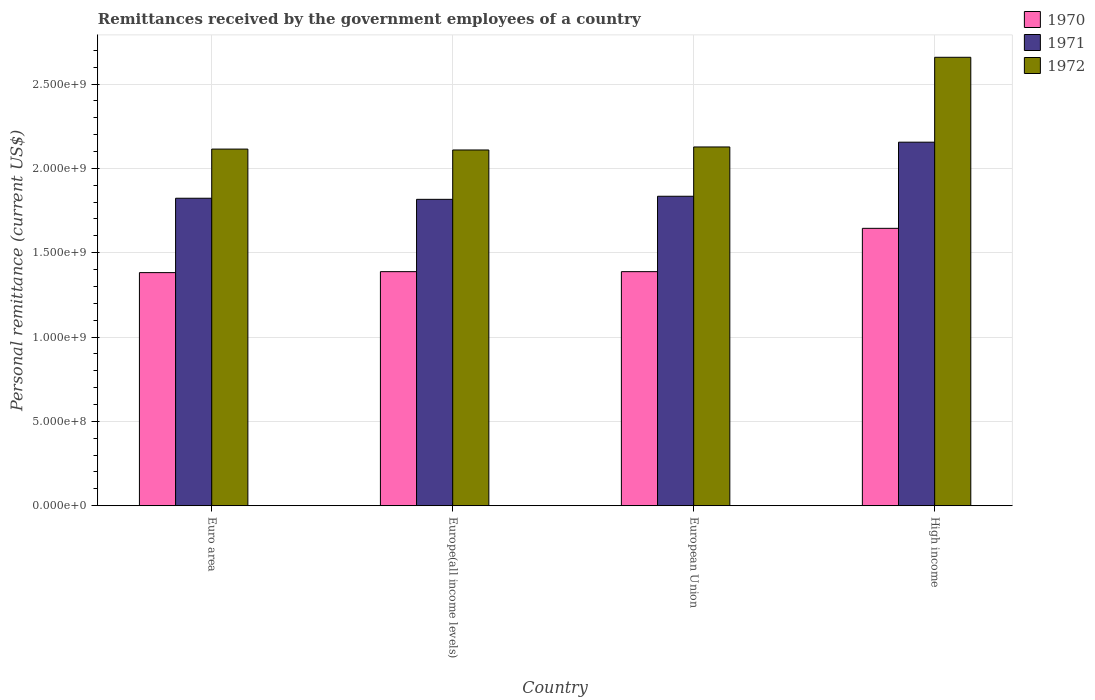How many groups of bars are there?
Make the answer very short. 4. Are the number of bars per tick equal to the number of legend labels?
Provide a short and direct response. Yes. Are the number of bars on each tick of the X-axis equal?
Give a very brief answer. Yes. How many bars are there on the 3rd tick from the right?
Your answer should be compact. 3. What is the label of the 4th group of bars from the left?
Your response must be concise. High income. What is the remittances received by the government employees in 1971 in European Union?
Offer a terse response. 1.83e+09. Across all countries, what is the maximum remittances received by the government employees in 1970?
Keep it short and to the point. 1.64e+09. Across all countries, what is the minimum remittances received by the government employees in 1972?
Your answer should be compact. 2.11e+09. In which country was the remittances received by the government employees in 1972 maximum?
Provide a short and direct response. High income. In which country was the remittances received by the government employees in 1972 minimum?
Provide a succinct answer. Europe(all income levels). What is the total remittances received by the government employees in 1971 in the graph?
Make the answer very short. 7.63e+09. What is the difference between the remittances received by the government employees in 1970 in Europe(all income levels) and that in High income?
Your response must be concise. -2.57e+08. What is the difference between the remittances received by the government employees in 1970 in High income and the remittances received by the government employees in 1971 in Euro area?
Provide a short and direct response. -1.78e+08. What is the average remittances received by the government employees in 1970 per country?
Your answer should be very brief. 1.45e+09. What is the difference between the remittances received by the government employees of/in 1972 and remittances received by the government employees of/in 1971 in European Union?
Make the answer very short. 2.92e+08. In how many countries, is the remittances received by the government employees in 1970 greater than 2400000000 US$?
Offer a terse response. 0. Is the remittances received by the government employees in 1972 in Euro area less than that in European Union?
Ensure brevity in your answer.  Yes. What is the difference between the highest and the second highest remittances received by the government employees in 1971?
Your response must be concise. -1.17e+07. What is the difference between the highest and the lowest remittances received by the government employees in 1970?
Provide a short and direct response. 2.63e+08. In how many countries, is the remittances received by the government employees in 1970 greater than the average remittances received by the government employees in 1970 taken over all countries?
Keep it short and to the point. 1. Is the sum of the remittances received by the government employees in 1971 in Euro area and European Union greater than the maximum remittances received by the government employees in 1972 across all countries?
Your answer should be very brief. Yes. Is it the case that in every country, the sum of the remittances received by the government employees in 1970 and remittances received by the government employees in 1972 is greater than the remittances received by the government employees in 1971?
Ensure brevity in your answer.  Yes. How many bars are there?
Offer a very short reply. 12. Are all the bars in the graph horizontal?
Provide a short and direct response. No. How many countries are there in the graph?
Offer a terse response. 4. Does the graph contain grids?
Make the answer very short. Yes. How are the legend labels stacked?
Ensure brevity in your answer.  Vertical. What is the title of the graph?
Offer a very short reply. Remittances received by the government employees of a country. Does "1987" appear as one of the legend labels in the graph?
Make the answer very short. No. What is the label or title of the Y-axis?
Your answer should be very brief. Personal remittance (current US$). What is the Personal remittance (current US$) of 1970 in Euro area?
Your response must be concise. 1.38e+09. What is the Personal remittance (current US$) in 1971 in Euro area?
Offer a terse response. 1.82e+09. What is the Personal remittance (current US$) of 1972 in Euro area?
Provide a succinct answer. 2.11e+09. What is the Personal remittance (current US$) of 1970 in Europe(all income levels)?
Offer a terse response. 1.39e+09. What is the Personal remittance (current US$) of 1971 in Europe(all income levels)?
Make the answer very short. 1.82e+09. What is the Personal remittance (current US$) in 1972 in Europe(all income levels)?
Provide a succinct answer. 2.11e+09. What is the Personal remittance (current US$) in 1970 in European Union?
Provide a succinct answer. 1.39e+09. What is the Personal remittance (current US$) of 1971 in European Union?
Provide a succinct answer. 1.83e+09. What is the Personal remittance (current US$) in 1972 in European Union?
Make the answer very short. 2.13e+09. What is the Personal remittance (current US$) of 1970 in High income?
Ensure brevity in your answer.  1.64e+09. What is the Personal remittance (current US$) in 1971 in High income?
Keep it short and to the point. 2.16e+09. What is the Personal remittance (current US$) of 1972 in High income?
Give a very brief answer. 2.66e+09. Across all countries, what is the maximum Personal remittance (current US$) in 1970?
Give a very brief answer. 1.64e+09. Across all countries, what is the maximum Personal remittance (current US$) in 1971?
Provide a succinct answer. 2.16e+09. Across all countries, what is the maximum Personal remittance (current US$) of 1972?
Give a very brief answer. 2.66e+09. Across all countries, what is the minimum Personal remittance (current US$) of 1970?
Ensure brevity in your answer.  1.38e+09. Across all countries, what is the minimum Personal remittance (current US$) of 1971?
Keep it short and to the point. 1.82e+09. Across all countries, what is the minimum Personal remittance (current US$) in 1972?
Make the answer very short. 2.11e+09. What is the total Personal remittance (current US$) in 1970 in the graph?
Offer a very short reply. 5.80e+09. What is the total Personal remittance (current US$) of 1971 in the graph?
Ensure brevity in your answer.  7.63e+09. What is the total Personal remittance (current US$) of 1972 in the graph?
Your answer should be compact. 9.01e+09. What is the difference between the Personal remittance (current US$) of 1970 in Euro area and that in Europe(all income levels)?
Provide a succinct answer. -5.80e+06. What is the difference between the Personal remittance (current US$) of 1971 in Euro area and that in Europe(all income levels)?
Give a very brief answer. 6.47e+06. What is the difference between the Personal remittance (current US$) of 1972 in Euro area and that in Europe(all income levels)?
Make the answer very short. 5.22e+06. What is the difference between the Personal remittance (current US$) of 1970 in Euro area and that in European Union?
Make the answer very short. -5.80e+06. What is the difference between the Personal remittance (current US$) in 1971 in Euro area and that in European Union?
Your answer should be very brief. -1.17e+07. What is the difference between the Personal remittance (current US$) in 1972 in Euro area and that in European Union?
Your response must be concise. -1.26e+07. What is the difference between the Personal remittance (current US$) in 1970 in Euro area and that in High income?
Offer a very short reply. -2.63e+08. What is the difference between the Personal remittance (current US$) of 1971 in Euro area and that in High income?
Your answer should be compact. -3.32e+08. What is the difference between the Personal remittance (current US$) in 1972 in Euro area and that in High income?
Your response must be concise. -5.44e+08. What is the difference between the Personal remittance (current US$) in 1971 in Europe(all income levels) and that in European Union?
Provide a succinct answer. -1.82e+07. What is the difference between the Personal remittance (current US$) in 1972 in Europe(all income levels) and that in European Union?
Provide a short and direct response. -1.78e+07. What is the difference between the Personal remittance (current US$) of 1970 in Europe(all income levels) and that in High income?
Offer a terse response. -2.57e+08. What is the difference between the Personal remittance (current US$) of 1971 in Europe(all income levels) and that in High income?
Offer a terse response. -3.39e+08. What is the difference between the Personal remittance (current US$) of 1972 in Europe(all income levels) and that in High income?
Your answer should be very brief. -5.49e+08. What is the difference between the Personal remittance (current US$) of 1970 in European Union and that in High income?
Provide a short and direct response. -2.57e+08. What is the difference between the Personal remittance (current US$) of 1971 in European Union and that in High income?
Provide a succinct answer. -3.21e+08. What is the difference between the Personal remittance (current US$) in 1972 in European Union and that in High income?
Your answer should be compact. -5.32e+08. What is the difference between the Personal remittance (current US$) of 1970 in Euro area and the Personal remittance (current US$) of 1971 in Europe(all income levels)?
Your answer should be compact. -4.35e+08. What is the difference between the Personal remittance (current US$) of 1970 in Euro area and the Personal remittance (current US$) of 1972 in Europe(all income levels)?
Your response must be concise. -7.27e+08. What is the difference between the Personal remittance (current US$) of 1971 in Euro area and the Personal remittance (current US$) of 1972 in Europe(all income levels)?
Your answer should be very brief. -2.86e+08. What is the difference between the Personal remittance (current US$) in 1970 in Euro area and the Personal remittance (current US$) in 1971 in European Union?
Give a very brief answer. -4.53e+08. What is the difference between the Personal remittance (current US$) of 1970 in Euro area and the Personal remittance (current US$) of 1972 in European Union?
Ensure brevity in your answer.  -7.45e+08. What is the difference between the Personal remittance (current US$) of 1971 in Euro area and the Personal remittance (current US$) of 1972 in European Union?
Keep it short and to the point. -3.04e+08. What is the difference between the Personal remittance (current US$) of 1970 in Euro area and the Personal remittance (current US$) of 1971 in High income?
Give a very brief answer. -7.73e+08. What is the difference between the Personal remittance (current US$) of 1970 in Euro area and the Personal remittance (current US$) of 1972 in High income?
Your response must be concise. -1.28e+09. What is the difference between the Personal remittance (current US$) of 1971 in Euro area and the Personal remittance (current US$) of 1972 in High income?
Keep it short and to the point. -8.36e+08. What is the difference between the Personal remittance (current US$) in 1970 in Europe(all income levels) and the Personal remittance (current US$) in 1971 in European Union?
Your response must be concise. -4.47e+08. What is the difference between the Personal remittance (current US$) in 1970 in Europe(all income levels) and the Personal remittance (current US$) in 1972 in European Union?
Offer a very short reply. -7.39e+08. What is the difference between the Personal remittance (current US$) in 1971 in Europe(all income levels) and the Personal remittance (current US$) in 1972 in European Union?
Your answer should be compact. -3.10e+08. What is the difference between the Personal remittance (current US$) of 1970 in Europe(all income levels) and the Personal remittance (current US$) of 1971 in High income?
Provide a succinct answer. -7.68e+08. What is the difference between the Personal remittance (current US$) of 1970 in Europe(all income levels) and the Personal remittance (current US$) of 1972 in High income?
Make the answer very short. -1.27e+09. What is the difference between the Personal remittance (current US$) in 1971 in Europe(all income levels) and the Personal remittance (current US$) in 1972 in High income?
Your answer should be compact. -8.42e+08. What is the difference between the Personal remittance (current US$) in 1970 in European Union and the Personal remittance (current US$) in 1971 in High income?
Your response must be concise. -7.68e+08. What is the difference between the Personal remittance (current US$) in 1970 in European Union and the Personal remittance (current US$) in 1972 in High income?
Provide a short and direct response. -1.27e+09. What is the difference between the Personal remittance (current US$) of 1971 in European Union and the Personal remittance (current US$) of 1972 in High income?
Ensure brevity in your answer.  -8.24e+08. What is the average Personal remittance (current US$) of 1970 per country?
Keep it short and to the point. 1.45e+09. What is the average Personal remittance (current US$) in 1971 per country?
Your answer should be very brief. 1.91e+09. What is the average Personal remittance (current US$) of 1972 per country?
Your answer should be compact. 2.25e+09. What is the difference between the Personal remittance (current US$) of 1970 and Personal remittance (current US$) of 1971 in Euro area?
Provide a short and direct response. -4.41e+08. What is the difference between the Personal remittance (current US$) of 1970 and Personal remittance (current US$) of 1972 in Euro area?
Offer a very short reply. -7.32e+08. What is the difference between the Personal remittance (current US$) in 1971 and Personal remittance (current US$) in 1972 in Euro area?
Offer a terse response. -2.91e+08. What is the difference between the Personal remittance (current US$) of 1970 and Personal remittance (current US$) of 1971 in Europe(all income levels)?
Provide a succinct answer. -4.29e+08. What is the difference between the Personal remittance (current US$) in 1970 and Personal remittance (current US$) in 1972 in Europe(all income levels)?
Provide a short and direct response. -7.21e+08. What is the difference between the Personal remittance (current US$) of 1971 and Personal remittance (current US$) of 1972 in Europe(all income levels)?
Your response must be concise. -2.93e+08. What is the difference between the Personal remittance (current US$) in 1970 and Personal remittance (current US$) in 1971 in European Union?
Offer a terse response. -4.47e+08. What is the difference between the Personal remittance (current US$) in 1970 and Personal remittance (current US$) in 1972 in European Union?
Make the answer very short. -7.39e+08. What is the difference between the Personal remittance (current US$) of 1971 and Personal remittance (current US$) of 1972 in European Union?
Give a very brief answer. -2.92e+08. What is the difference between the Personal remittance (current US$) in 1970 and Personal remittance (current US$) in 1971 in High income?
Provide a short and direct response. -5.11e+08. What is the difference between the Personal remittance (current US$) in 1970 and Personal remittance (current US$) in 1972 in High income?
Your answer should be very brief. -1.01e+09. What is the difference between the Personal remittance (current US$) of 1971 and Personal remittance (current US$) of 1972 in High income?
Give a very brief answer. -5.03e+08. What is the ratio of the Personal remittance (current US$) in 1970 in Euro area to that in Europe(all income levels)?
Offer a terse response. 1. What is the ratio of the Personal remittance (current US$) of 1972 in Euro area to that in Europe(all income levels)?
Your answer should be compact. 1. What is the ratio of the Personal remittance (current US$) of 1971 in Euro area to that in European Union?
Your answer should be very brief. 0.99. What is the ratio of the Personal remittance (current US$) in 1970 in Euro area to that in High income?
Provide a succinct answer. 0.84. What is the ratio of the Personal remittance (current US$) in 1971 in Euro area to that in High income?
Your answer should be very brief. 0.85. What is the ratio of the Personal remittance (current US$) of 1972 in Euro area to that in High income?
Your answer should be compact. 0.8. What is the ratio of the Personal remittance (current US$) of 1970 in Europe(all income levels) to that in European Union?
Your answer should be compact. 1. What is the ratio of the Personal remittance (current US$) of 1970 in Europe(all income levels) to that in High income?
Provide a short and direct response. 0.84. What is the ratio of the Personal remittance (current US$) in 1971 in Europe(all income levels) to that in High income?
Offer a terse response. 0.84. What is the ratio of the Personal remittance (current US$) of 1972 in Europe(all income levels) to that in High income?
Offer a terse response. 0.79. What is the ratio of the Personal remittance (current US$) of 1970 in European Union to that in High income?
Your answer should be very brief. 0.84. What is the ratio of the Personal remittance (current US$) in 1971 in European Union to that in High income?
Keep it short and to the point. 0.85. What is the difference between the highest and the second highest Personal remittance (current US$) of 1970?
Provide a short and direct response. 2.57e+08. What is the difference between the highest and the second highest Personal remittance (current US$) in 1971?
Give a very brief answer. 3.21e+08. What is the difference between the highest and the second highest Personal remittance (current US$) in 1972?
Your response must be concise. 5.32e+08. What is the difference between the highest and the lowest Personal remittance (current US$) in 1970?
Your response must be concise. 2.63e+08. What is the difference between the highest and the lowest Personal remittance (current US$) of 1971?
Offer a terse response. 3.39e+08. What is the difference between the highest and the lowest Personal remittance (current US$) of 1972?
Give a very brief answer. 5.49e+08. 